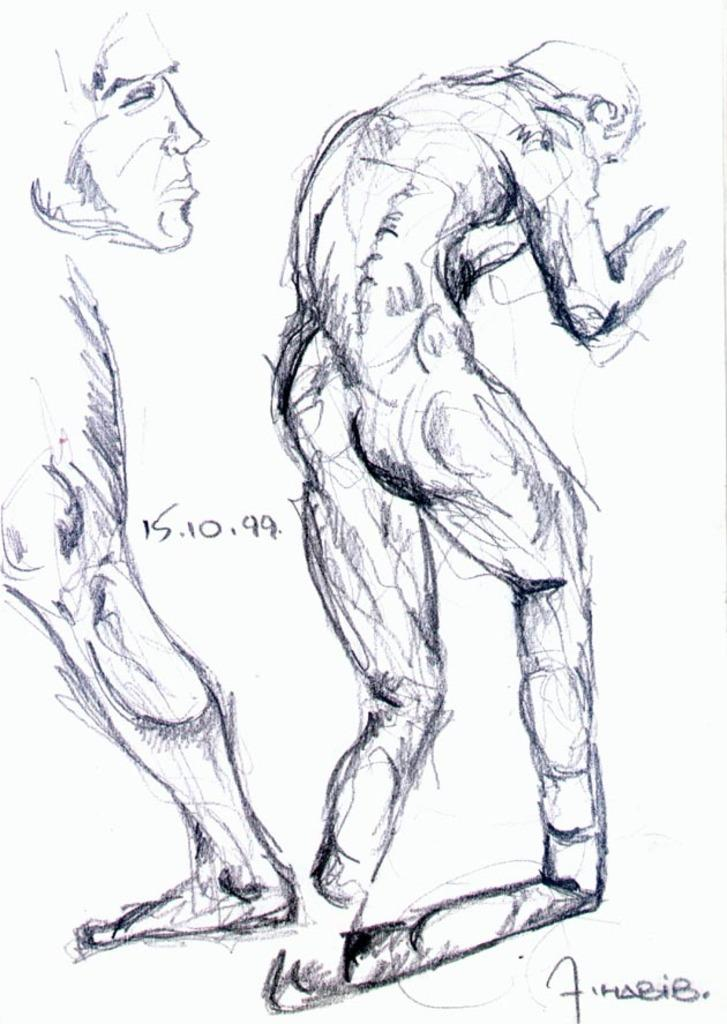What is depicted in the image? There is a sketch of a person in the image. Can you see the coach and partner of the person in the sketch? There is no coach or partner present in the image; it only features a sketch of a person. 